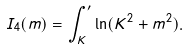<formula> <loc_0><loc_0><loc_500><loc_500>I _ { 4 } ( m ) = \int _ { K } ^ { \prime } \ln ( K ^ { 2 } + m ^ { 2 } ) .</formula> 